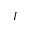Convert formula to latex. <formula><loc_0><loc_0><loc_500><loc_500>I</formula> 